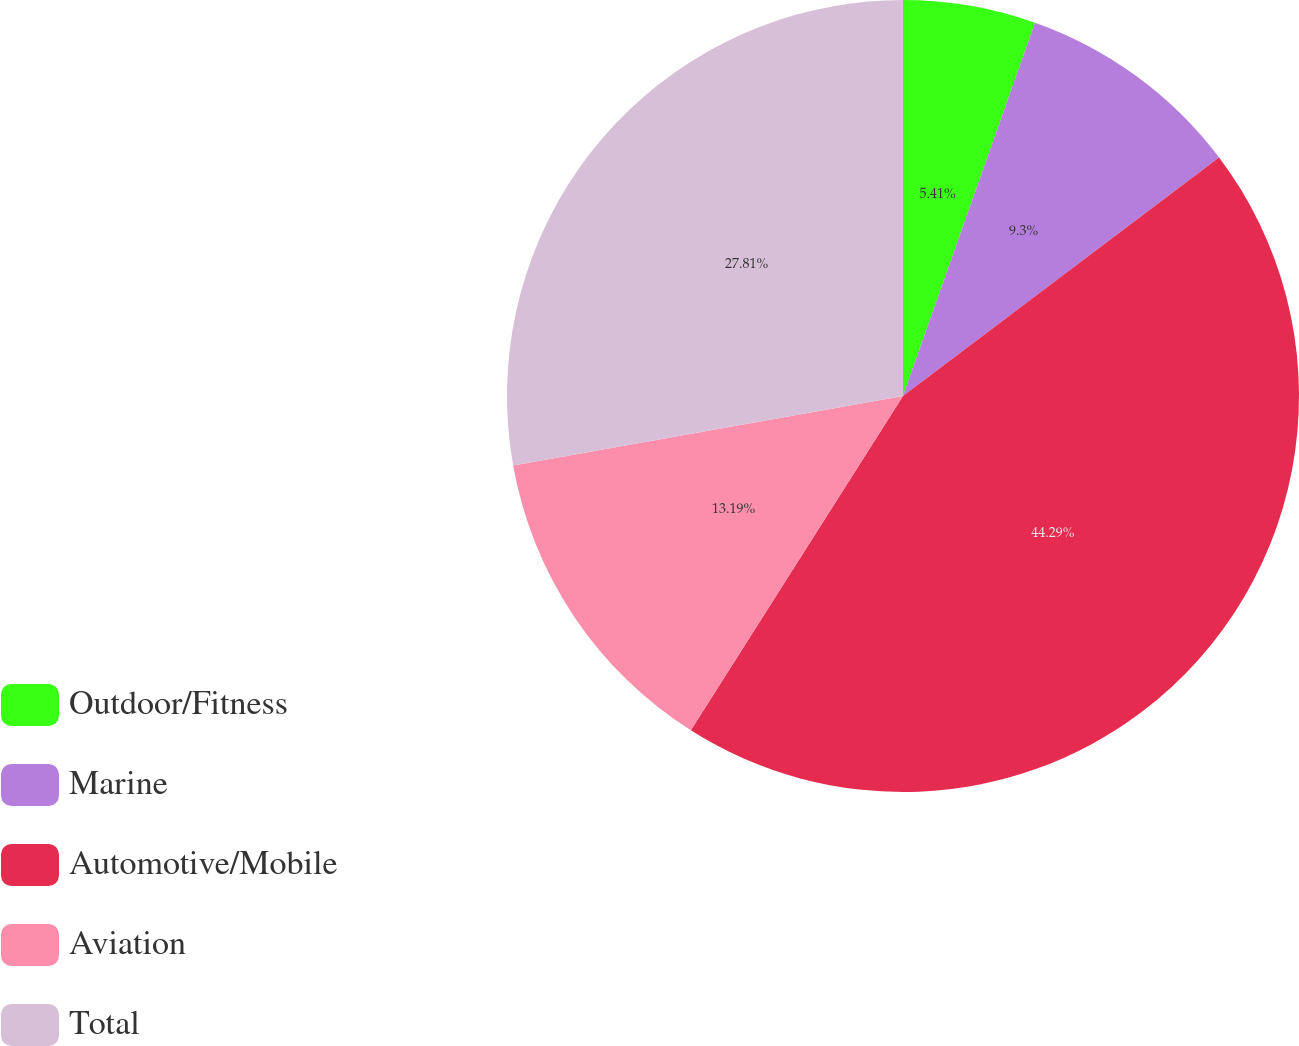Convert chart. <chart><loc_0><loc_0><loc_500><loc_500><pie_chart><fcel>Outdoor/Fitness<fcel>Marine<fcel>Automotive/Mobile<fcel>Aviation<fcel>Total<nl><fcel>5.41%<fcel>9.3%<fcel>44.29%<fcel>13.19%<fcel>27.81%<nl></chart> 